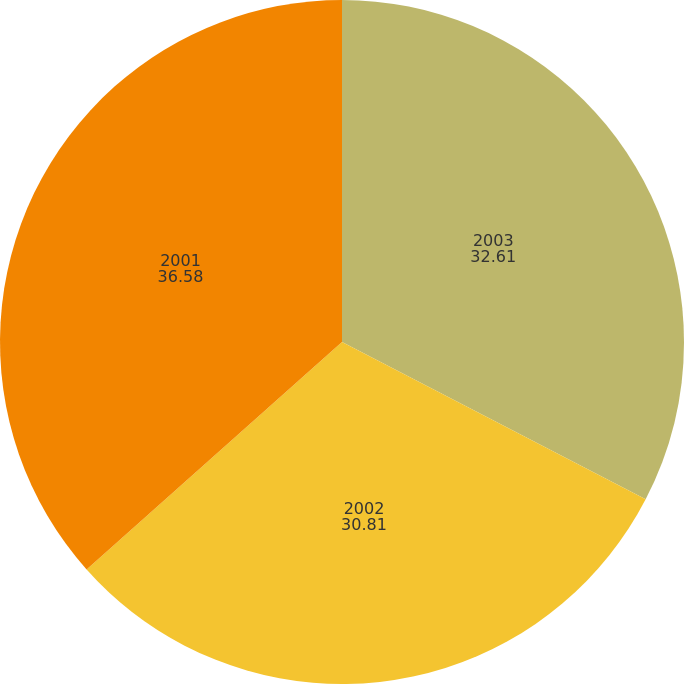<chart> <loc_0><loc_0><loc_500><loc_500><pie_chart><fcel>2003<fcel>2002<fcel>2001<nl><fcel>32.61%<fcel>30.81%<fcel>36.58%<nl></chart> 